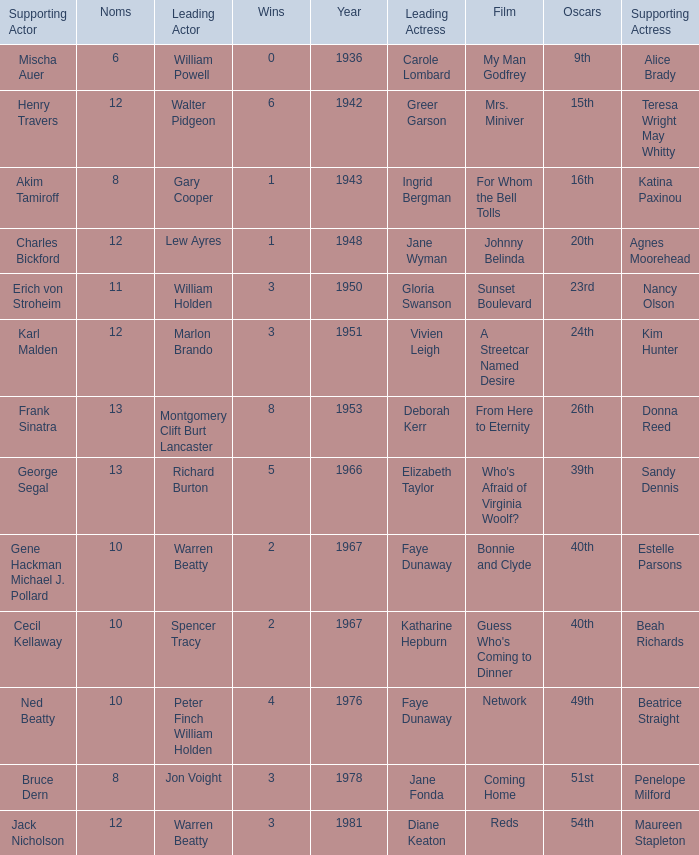Parse the table in full. {'header': ['Supporting Actor', 'Noms', 'Leading Actor', 'Wins', 'Year', 'Leading Actress', 'Film', 'Oscars', 'Supporting Actress'], 'rows': [['Mischa Auer', '6', 'William Powell', '0', '1936', 'Carole Lombard', 'My Man Godfrey', '9th', 'Alice Brady'], ['Henry Travers', '12', 'Walter Pidgeon', '6', '1942', 'Greer Garson', 'Mrs. Miniver', '15th', 'Teresa Wright May Whitty'], ['Akim Tamiroff', '8', 'Gary Cooper', '1', '1943', 'Ingrid Bergman', 'For Whom the Bell Tolls', '16th', 'Katina Paxinou'], ['Charles Bickford', '12', 'Lew Ayres', '1', '1948', 'Jane Wyman', 'Johnny Belinda', '20th', 'Agnes Moorehead'], ['Erich von Stroheim', '11', 'William Holden', '3', '1950', 'Gloria Swanson', 'Sunset Boulevard', '23rd', 'Nancy Olson'], ['Karl Malden', '12', 'Marlon Brando', '3', '1951', 'Vivien Leigh', 'A Streetcar Named Desire', '24th', 'Kim Hunter'], ['Frank Sinatra', '13', 'Montgomery Clift Burt Lancaster', '8', '1953', 'Deborah Kerr', 'From Here to Eternity', '26th', 'Donna Reed'], ['George Segal', '13', 'Richard Burton', '5', '1966', 'Elizabeth Taylor', "Who's Afraid of Virginia Woolf?", '39th', 'Sandy Dennis'], ['Gene Hackman Michael J. Pollard', '10', 'Warren Beatty', '2', '1967', 'Faye Dunaway', 'Bonnie and Clyde', '40th', 'Estelle Parsons'], ['Cecil Kellaway', '10', 'Spencer Tracy', '2', '1967', 'Katharine Hepburn', "Guess Who's Coming to Dinner", '40th', 'Beah Richards'], ['Ned Beatty', '10', 'Peter Finch William Holden', '4', '1976', 'Faye Dunaway', 'Network', '49th', 'Beatrice Straight'], ['Bruce Dern', '8', 'Jon Voight', '3', '1978', 'Jane Fonda', 'Coming Home', '51st', 'Penelope Milford'], ['Jack Nicholson', '12', 'Warren Beatty', '3', '1981', 'Diane Keaton', 'Reds', '54th', 'Maureen Stapleton']]} Who was the leading actress in a film with Warren Beatty as the leading actor and also at the 40th Oscars? Faye Dunaway. 